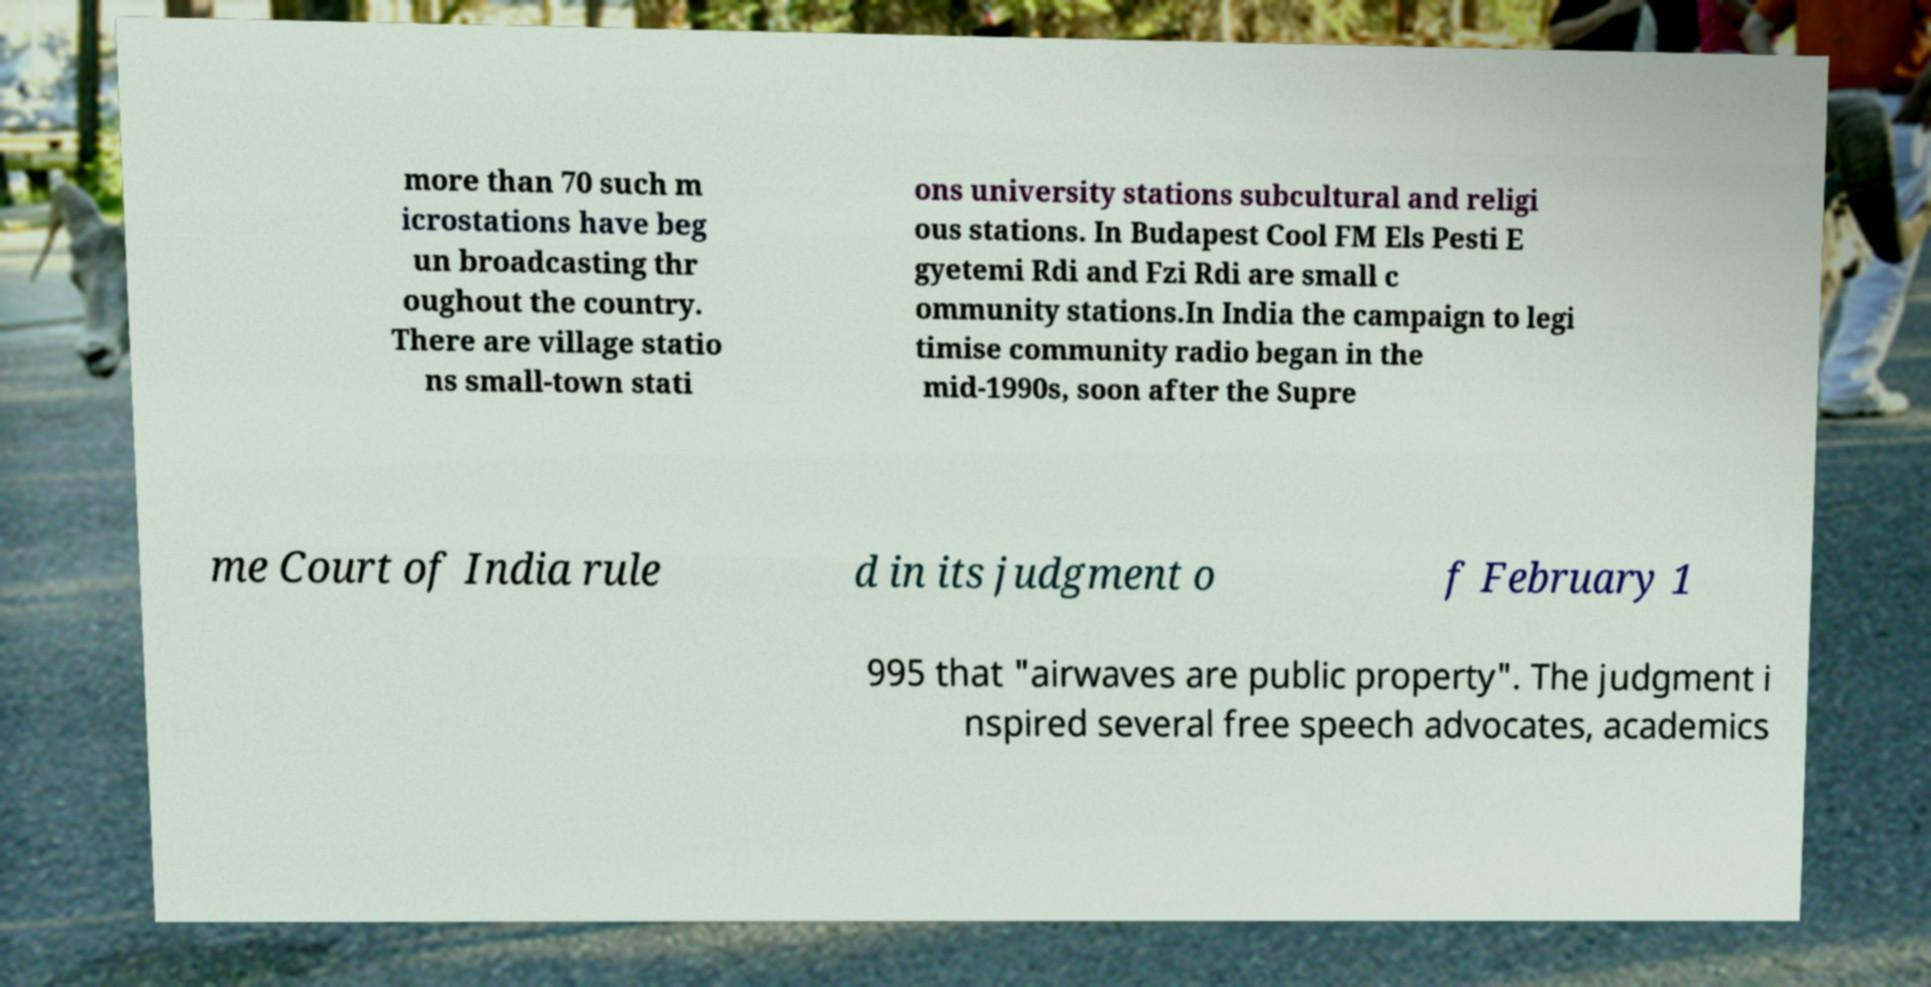Can you accurately transcribe the text from the provided image for me? more than 70 such m icrostations have beg un broadcasting thr oughout the country. There are village statio ns small-town stati ons university stations subcultural and religi ous stations. In Budapest Cool FM Els Pesti E gyetemi Rdi and Fzi Rdi are small c ommunity stations.In India the campaign to legi timise community radio began in the mid-1990s, soon after the Supre me Court of India rule d in its judgment o f February 1 995 that "airwaves are public property". The judgment i nspired several free speech advocates, academics 